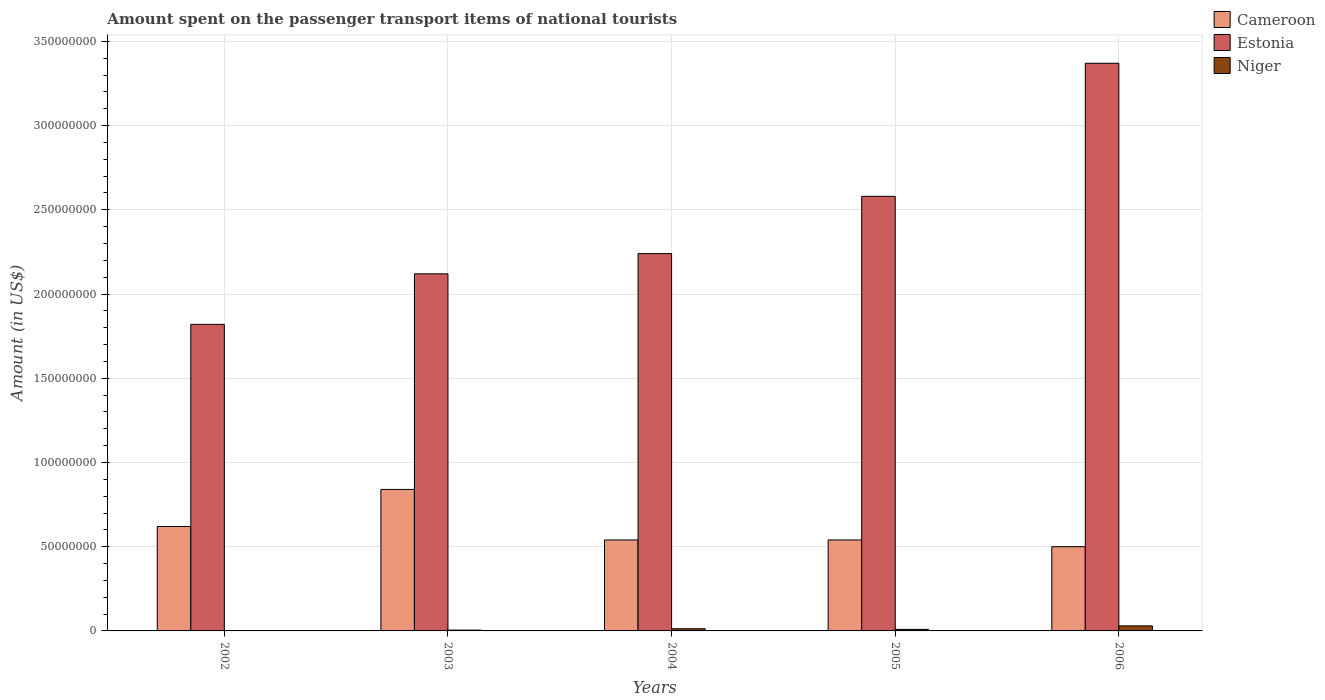Are the number of bars on each tick of the X-axis equal?
Ensure brevity in your answer.  Yes. What is the label of the 4th group of bars from the left?
Your response must be concise. 2005. What is the amount spent on the passenger transport items of national tourists in Cameroon in 2004?
Your response must be concise. 5.40e+07. Across all years, what is the maximum amount spent on the passenger transport items of national tourists in Cameroon?
Your answer should be very brief. 8.40e+07. Across all years, what is the minimum amount spent on the passenger transport items of national tourists in Estonia?
Offer a terse response. 1.82e+08. What is the total amount spent on the passenger transport items of national tourists in Cameroon in the graph?
Provide a short and direct response. 3.04e+08. What is the difference between the amount spent on the passenger transport items of national tourists in Cameroon in 2002 and that in 2003?
Offer a very short reply. -2.20e+07. What is the difference between the amount spent on the passenger transport items of national tourists in Cameroon in 2005 and the amount spent on the passenger transport items of national tourists in Niger in 2003?
Make the answer very short. 5.35e+07. What is the average amount spent on the passenger transport items of national tourists in Cameroon per year?
Your answer should be compact. 6.08e+07. In the year 2002, what is the difference between the amount spent on the passenger transport items of national tourists in Estonia and amount spent on the passenger transport items of national tourists in Niger?
Keep it short and to the point. 1.82e+08. What is the ratio of the amount spent on the passenger transport items of national tourists in Niger in 2004 to that in 2006?
Make the answer very short. 0.43. Is the amount spent on the passenger transport items of national tourists in Niger in 2004 less than that in 2006?
Your answer should be very brief. Yes. What is the difference between the highest and the second highest amount spent on the passenger transport items of national tourists in Niger?
Ensure brevity in your answer.  1.70e+06. What is the difference between the highest and the lowest amount spent on the passenger transport items of national tourists in Niger?
Offer a very short reply. 2.80e+06. What does the 2nd bar from the left in 2003 represents?
Offer a very short reply. Estonia. What does the 1st bar from the right in 2006 represents?
Your response must be concise. Niger. Is it the case that in every year, the sum of the amount spent on the passenger transport items of national tourists in Cameroon and amount spent on the passenger transport items of national tourists in Estonia is greater than the amount spent on the passenger transport items of national tourists in Niger?
Make the answer very short. Yes. What is the difference between two consecutive major ticks on the Y-axis?
Keep it short and to the point. 5.00e+07. Are the values on the major ticks of Y-axis written in scientific E-notation?
Offer a terse response. No. Does the graph contain any zero values?
Provide a short and direct response. No. Does the graph contain grids?
Make the answer very short. Yes. How many legend labels are there?
Provide a succinct answer. 3. What is the title of the graph?
Provide a succinct answer. Amount spent on the passenger transport items of national tourists. Does "Sudan" appear as one of the legend labels in the graph?
Provide a short and direct response. No. What is the Amount (in US$) of Cameroon in 2002?
Your answer should be compact. 6.20e+07. What is the Amount (in US$) of Estonia in 2002?
Offer a terse response. 1.82e+08. What is the Amount (in US$) in Niger in 2002?
Ensure brevity in your answer.  2.00e+05. What is the Amount (in US$) of Cameroon in 2003?
Your response must be concise. 8.40e+07. What is the Amount (in US$) in Estonia in 2003?
Your answer should be compact. 2.12e+08. What is the Amount (in US$) in Niger in 2003?
Keep it short and to the point. 5.00e+05. What is the Amount (in US$) in Cameroon in 2004?
Offer a terse response. 5.40e+07. What is the Amount (in US$) of Estonia in 2004?
Provide a succinct answer. 2.24e+08. What is the Amount (in US$) in Niger in 2004?
Your answer should be very brief. 1.30e+06. What is the Amount (in US$) in Cameroon in 2005?
Your answer should be compact. 5.40e+07. What is the Amount (in US$) of Estonia in 2005?
Your response must be concise. 2.58e+08. What is the Amount (in US$) of Cameroon in 2006?
Offer a terse response. 5.00e+07. What is the Amount (in US$) of Estonia in 2006?
Keep it short and to the point. 3.37e+08. Across all years, what is the maximum Amount (in US$) in Cameroon?
Provide a succinct answer. 8.40e+07. Across all years, what is the maximum Amount (in US$) of Estonia?
Offer a terse response. 3.37e+08. Across all years, what is the maximum Amount (in US$) in Niger?
Provide a succinct answer. 3.00e+06. Across all years, what is the minimum Amount (in US$) in Cameroon?
Provide a short and direct response. 5.00e+07. Across all years, what is the minimum Amount (in US$) in Estonia?
Ensure brevity in your answer.  1.82e+08. Across all years, what is the minimum Amount (in US$) of Niger?
Keep it short and to the point. 2.00e+05. What is the total Amount (in US$) of Cameroon in the graph?
Offer a terse response. 3.04e+08. What is the total Amount (in US$) of Estonia in the graph?
Your answer should be very brief. 1.21e+09. What is the total Amount (in US$) of Niger in the graph?
Offer a very short reply. 5.90e+06. What is the difference between the Amount (in US$) in Cameroon in 2002 and that in 2003?
Your response must be concise. -2.20e+07. What is the difference between the Amount (in US$) of Estonia in 2002 and that in 2003?
Offer a terse response. -3.00e+07. What is the difference between the Amount (in US$) in Estonia in 2002 and that in 2004?
Offer a very short reply. -4.20e+07. What is the difference between the Amount (in US$) in Niger in 2002 and that in 2004?
Offer a terse response. -1.10e+06. What is the difference between the Amount (in US$) of Estonia in 2002 and that in 2005?
Keep it short and to the point. -7.60e+07. What is the difference between the Amount (in US$) of Niger in 2002 and that in 2005?
Ensure brevity in your answer.  -7.00e+05. What is the difference between the Amount (in US$) of Cameroon in 2002 and that in 2006?
Your response must be concise. 1.20e+07. What is the difference between the Amount (in US$) of Estonia in 2002 and that in 2006?
Your response must be concise. -1.55e+08. What is the difference between the Amount (in US$) of Niger in 2002 and that in 2006?
Give a very brief answer. -2.80e+06. What is the difference between the Amount (in US$) of Cameroon in 2003 and that in 2004?
Ensure brevity in your answer.  3.00e+07. What is the difference between the Amount (in US$) of Estonia in 2003 and that in 2004?
Ensure brevity in your answer.  -1.20e+07. What is the difference between the Amount (in US$) of Niger in 2003 and that in 2004?
Make the answer very short. -8.00e+05. What is the difference between the Amount (in US$) of Cameroon in 2003 and that in 2005?
Your response must be concise. 3.00e+07. What is the difference between the Amount (in US$) in Estonia in 2003 and that in 2005?
Your answer should be compact. -4.60e+07. What is the difference between the Amount (in US$) in Niger in 2003 and that in 2005?
Your answer should be compact. -4.00e+05. What is the difference between the Amount (in US$) of Cameroon in 2003 and that in 2006?
Give a very brief answer. 3.40e+07. What is the difference between the Amount (in US$) in Estonia in 2003 and that in 2006?
Offer a terse response. -1.25e+08. What is the difference between the Amount (in US$) in Niger in 2003 and that in 2006?
Give a very brief answer. -2.50e+06. What is the difference between the Amount (in US$) of Cameroon in 2004 and that in 2005?
Provide a short and direct response. 0. What is the difference between the Amount (in US$) of Estonia in 2004 and that in 2005?
Your answer should be very brief. -3.40e+07. What is the difference between the Amount (in US$) of Cameroon in 2004 and that in 2006?
Provide a succinct answer. 4.00e+06. What is the difference between the Amount (in US$) of Estonia in 2004 and that in 2006?
Offer a terse response. -1.13e+08. What is the difference between the Amount (in US$) of Niger in 2004 and that in 2006?
Provide a succinct answer. -1.70e+06. What is the difference between the Amount (in US$) of Cameroon in 2005 and that in 2006?
Offer a very short reply. 4.00e+06. What is the difference between the Amount (in US$) of Estonia in 2005 and that in 2006?
Your answer should be compact. -7.90e+07. What is the difference between the Amount (in US$) of Niger in 2005 and that in 2006?
Ensure brevity in your answer.  -2.10e+06. What is the difference between the Amount (in US$) in Cameroon in 2002 and the Amount (in US$) in Estonia in 2003?
Offer a very short reply. -1.50e+08. What is the difference between the Amount (in US$) of Cameroon in 2002 and the Amount (in US$) of Niger in 2003?
Keep it short and to the point. 6.15e+07. What is the difference between the Amount (in US$) of Estonia in 2002 and the Amount (in US$) of Niger in 2003?
Your response must be concise. 1.82e+08. What is the difference between the Amount (in US$) of Cameroon in 2002 and the Amount (in US$) of Estonia in 2004?
Provide a short and direct response. -1.62e+08. What is the difference between the Amount (in US$) of Cameroon in 2002 and the Amount (in US$) of Niger in 2004?
Keep it short and to the point. 6.07e+07. What is the difference between the Amount (in US$) of Estonia in 2002 and the Amount (in US$) of Niger in 2004?
Provide a short and direct response. 1.81e+08. What is the difference between the Amount (in US$) of Cameroon in 2002 and the Amount (in US$) of Estonia in 2005?
Ensure brevity in your answer.  -1.96e+08. What is the difference between the Amount (in US$) in Cameroon in 2002 and the Amount (in US$) in Niger in 2005?
Keep it short and to the point. 6.11e+07. What is the difference between the Amount (in US$) in Estonia in 2002 and the Amount (in US$) in Niger in 2005?
Your answer should be compact. 1.81e+08. What is the difference between the Amount (in US$) in Cameroon in 2002 and the Amount (in US$) in Estonia in 2006?
Your response must be concise. -2.75e+08. What is the difference between the Amount (in US$) of Cameroon in 2002 and the Amount (in US$) of Niger in 2006?
Give a very brief answer. 5.90e+07. What is the difference between the Amount (in US$) in Estonia in 2002 and the Amount (in US$) in Niger in 2006?
Offer a terse response. 1.79e+08. What is the difference between the Amount (in US$) of Cameroon in 2003 and the Amount (in US$) of Estonia in 2004?
Provide a short and direct response. -1.40e+08. What is the difference between the Amount (in US$) in Cameroon in 2003 and the Amount (in US$) in Niger in 2004?
Provide a succinct answer. 8.27e+07. What is the difference between the Amount (in US$) of Estonia in 2003 and the Amount (in US$) of Niger in 2004?
Give a very brief answer. 2.11e+08. What is the difference between the Amount (in US$) of Cameroon in 2003 and the Amount (in US$) of Estonia in 2005?
Provide a short and direct response. -1.74e+08. What is the difference between the Amount (in US$) of Cameroon in 2003 and the Amount (in US$) of Niger in 2005?
Provide a succinct answer. 8.31e+07. What is the difference between the Amount (in US$) of Estonia in 2003 and the Amount (in US$) of Niger in 2005?
Provide a short and direct response. 2.11e+08. What is the difference between the Amount (in US$) of Cameroon in 2003 and the Amount (in US$) of Estonia in 2006?
Give a very brief answer. -2.53e+08. What is the difference between the Amount (in US$) of Cameroon in 2003 and the Amount (in US$) of Niger in 2006?
Your answer should be compact. 8.10e+07. What is the difference between the Amount (in US$) of Estonia in 2003 and the Amount (in US$) of Niger in 2006?
Provide a succinct answer. 2.09e+08. What is the difference between the Amount (in US$) of Cameroon in 2004 and the Amount (in US$) of Estonia in 2005?
Provide a short and direct response. -2.04e+08. What is the difference between the Amount (in US$) of Cameroon in 2004 and the Amount (in US$) of Niger in 2005?
Keep it short and to the point. 5.31e+07. What is the difference between the Amount (in US$) in Estonia in 2004 and the Amount (in US$) in Niger in 2005?
Your answer should be very brief. 2.23e+08. What is the difference between the Amount (in US$) of Cameroon in 2004 and the Amount (in US$) of Estonia in 2006?
Ensure brevity in your answer.  -2.83e+08. What is the difference between the Amount (in US$) in Cameroon in 2004 and the Amount (in US$) in Niger in 2006?
Your answer should be very brief. 5.10e+07. What is the difference between the Amount (in US$) in Estonia in 2004 and the Amount (in US$) in Niger in 2006?
Your answer should be very brief. 2.21e+08. What is the difference between the Amount (in US$) of Cameroon in 2005 and the Amount (in US$) of Estonia in 2006?
Offer a very short reply. -2.83e+08. What is the difference between the Amount (in US$) of Cameroon in 2005 and the Amount (in US$) of Niger in 2006?
Keep it short and to the point. 5.10e+07. What is the difference between the Amount (in US$) of Estonia in 2005 and the Amount (in US$) of Niger in 2006?
Provide a succinct answer. 2.55e+08. What is the average Amount (in US$) of Cameroon per year?
Your answer should be compact. 6.08e+07. What is the average Amount (in US$) of Estonia per year?
Ensure brevity in your answer.  2.43e+08. What is the average Amount (in US$) of Niger per year?
Make the answer very short. 1.18e+06. In the year 2002, what is the difference between the Amount (in US$) of Cameroon and Amount (in US$) of Estonia?
Give a very brief answer. -1.20e+08. In the year 2002, what is the difference between the Amount (in US$) in Cameroon and Amount (in US$) in Niger?
Your answer should be very brief. 6.18e+07. In the year 2002, what is the difference between the Amount (in US$) in Estonia and Amount (in US$) in Niger?
Your response must be concise. 1.82e+08. In the year 2003, what is the difference between the Amount (in US$) of Cameroon and Amount (in US$) of Estonia?
Make the answer very short. -1.28e+08. In the year 2003, what is the difference between the Amount (in US$) in Cameroon and Amount (in US$) in Niger?
Provide a short and direct response. 8.35e+07. In the year 2003, what is the difference between the Amount (in US$) in Estonia and Amount (in US$) in Niger?
Ensure brevity in your answer.  2.12e+08. In the year 2004, what is the difference between the Amount (in US$) in Cameroon and Amount (in US$) in Estonia?
Ensure brevity in your answer.  -1.70e+08. In the year 2004, what is the difference between the Amount (in US$) of Cameroon and Amount (in US$) of Niger?
Your answer should be compact. 5.27e+07. In the year 2004, what is the difference between the Amount (in US$) of Estonia and Amount (in US$) of Niger?
Keep it short and to the point. 2.23e+08. In the year 2005, what is the difference between the Amount (in US$) in Cameroon and Amount (in US$) in Estonia?
Keep it short and to the point. -2.04e+08. In the year 2005, what is the difference between the Amount (in US$) in Cameroon and Amount (in US$) in Niger?
Provide a short and direct response. 5.31e+07. In the year 2005, what is the difference between the Amount (in US$) in Estonia and Amount (in US$) in Niger?
Offer a very short reply. 2.57e+08. In the year 2006, what is the difference between the Amount (in US$) in Cameroon and Amount (in US$) in Estonia?
Offer a terse response. -2.87e+08. In the year 2006, what is the difference between the Amount (in US$) in Cameroon and Amount (in US$) in Niger?
Give a very brief answer. 4.70e+07. In the year 2006, what is the difference between the Amount (in US$) of Estonia and Amount (in US$) of Niger?
Your answer should be compact. 3.34e+08. What is the ratio of the Amount (in US$) in Cameroon in 2002 to that in 2003?
Your answer should be compact. 0.74. What is the ratio of the Amount (in US$) in Estonia in 2002 to that in 2003?
Offer a very short reply. 0.86. What is the ratio of the Amount (in US$) of Niger in 2002 to that in 2003?
Keep it short and to the point. 0.4. What is the ratio of the Amount (in US$) in Cameroon in 2002 to that in 2004?
Provide a succinct answer. 1.15. What is the ratio of the Amount (in US$) of Estonia in 2002 to that in 2004?
Keep it short and to the point. 0.81. What is the ratio of the Amount (in US$) of Niger in 2002 to that in 2004?
Provide a short and direct response. 0.15. What is the ratio of the Amount (in US$) in Cameroon in 2002 to that in 2005?
Provide a short and direct response. 1.15. What is the ratio of the Amount (in US$) of Estonia in 2002 to that in 2005?
Your response must be concise. 0.71. What is the ratio of the Amount (in US$) of Niger in 2002 to that in 2005?
Your answer should be compact. 0.22. What is the ratio of the Amount (in US$) in Cameroon in 2002 to that in 2006?
Offer a terse response. 1.24. What is the ratio of the Amount (in US$) of Estonia in 2002 to that in 2006?
Ensure brevity in your answer.  0.54. What is the ratio of the Amount (in US$) in Niger in 2002 to that in 2006?
Your answer should be compact. 0.07. What is the ratio of the Amount (in US$) of Cameroon in 2003 to that in 2004?
Offer a very short reply. 1.56. What is the ratio of the Amount (in US$) of Estonia in 2003 to that in 2004?
Keep it short and to the point. 0.95. What is the ratio of the Amount (in US$) in Niger in 2003 to that in 2004?
Your response must be concise. 0.38. What is the ratio of the Amount (in US$) in Cameroon in 2003 to that in 2005?
Your answer should be compact. 1.56. What is the ratio of the Amount (in US$) of Estonia in 2003 to that in 2005?
Offer a terse response. 0.82. What is the ratio of the Amount (in US$) of Niger in 2003 to that in 2005?
Ensure brevity in your answer.  0.56. What is the ratio of the Amount (in US$) of Cameroon in 2003 to that in 2006?
Your answer should be very brief. 1.68. What is the ratio of the Amount (in US$) in Estonia in 2003 to that in 2006?
Your answer should be very brief. 0.63. What is the ratio of the Amount (in US$) in Niger in 2003 to that in 2006?
Keep it short and to the point. 0.17. What is the ratio of the Amount (in US$) in Cameroon in 2004 to that in 2005?
Your answer should be compact. 1. What is the ratio of the Amount (in US$) in Estonia in 2004 to that in 2005?
Give a very brief answer. 0.87. What is the ratio of the Amount (in US$) of Niger in 2004 to that in 2005?
Offer a very short reply. 1.44. What is the ratio of the Amount (in US$) in Cameroon in 2004 to that in 2006?
Provide a short and direct response. 1.08. What is the ratio of the Amount (in US$) of Estonia in 2004 to that in 2006?
Offer a very short reply. 0.66. What is the ratio of the Amount (in US$) of Niger in 2004 to that in 2006?
Offer a very short reply. 0.43. What is the ratio of the Amount (in US$) in Estonia in 2005 to that in 2006?
Provide a succinct answer. 0.77. What is the difference between the highest and the second highest Amount (in US$) in Cameroon?
Offer a very short reply. 2.20e+07. What is the difference between the highest and the second highest Amount (in US$) of Estonia?
Keep it short and to the point. 7.90e+07. What is the difference between the highest and the second highest Amount (in US$) in Niger?
Ensure brevity in your answer.  1.70e+06. What is the difference between the highest and the lowest Amount (in US$) of Cameroon?
Provide a short and direct response. 3.40e+07. What is the difference between the highest and the lowest Amount (in US$) in Estonia?
Your answer should be compact. 1.55e+08. What is the difference between the highest and the lowest Amount (in US$) of Niger?
Provide a short and direct response. 2.80e+06. 